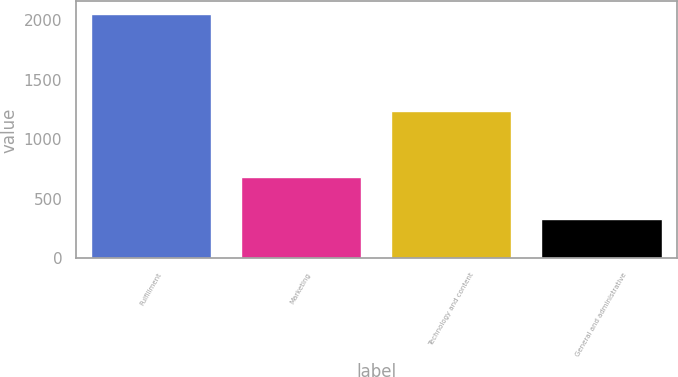Convert chart. <chart><loc_0><loc_0><loc_500><loc_500><bar_chart><fcel>Fulfillment<fcel>Marketing<fcel>Technology and content<fcel>General and administrative<nl><fcel>2052<fcel>680<fcel>1240<fcel>328<nl></chart> 